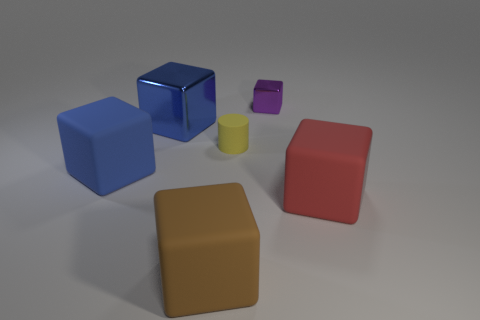Subtract all blue matte cubes. How many cubes are left? 4 Add 2 gray matte blocks. How many gray matte blocks exist? 2 Add 3 large yellow matte cubes. How many objects exist? 9 Subtract all purple blocks. How many blocks are left? 4 Subtract 0 green balls. How many objects are left? 6 Subtract all blocks. How many objects are left? 1 Subtract 1 cylinders. How many cylinders are left? 0 Subtract all brown cylinders. Subtract all red cubes. How many cylinders are left? 1 Subtract all cyan balls. How many gray cylinders are left? 0 Subtract all rubber things. Subtract all tiny cylinders. How many objects are left? 1 